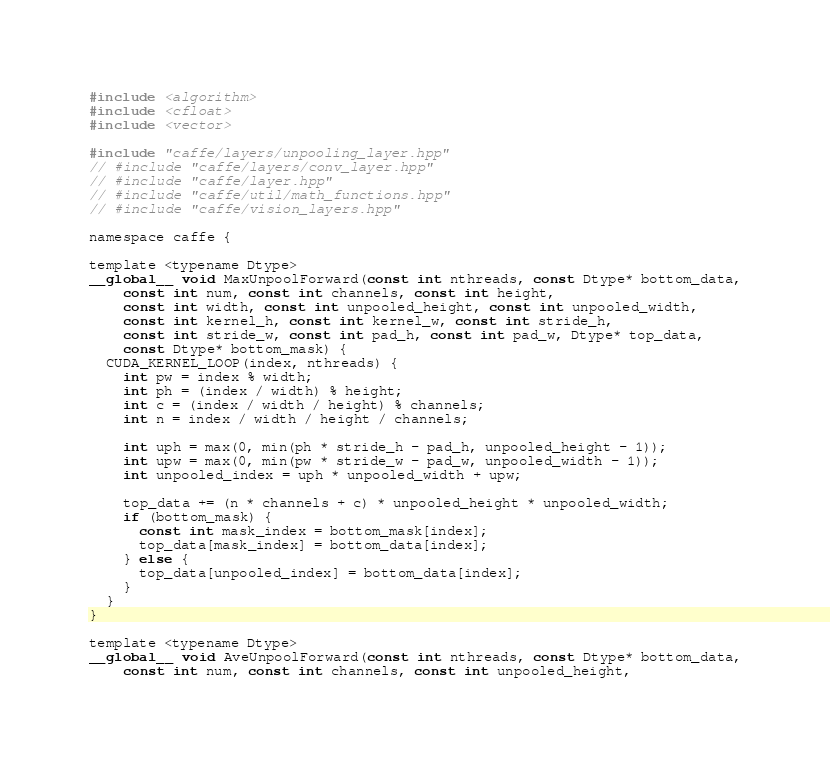<code> <loc_0><loc_0><loc_500><loc_500><_Cuda_>#include <algorithm>
#include <cfloat>
#include <vector>

#include "caffe/layers/unpooling_layer.hpp"
// #include "caffe/layers/conv_layer.hpp"
// #include "caffe/layer.hpp"
// #include "caffe/util/math_functions.hpp"
// #include "caffe/vision_layers.hpp"

namespace caffe {

template <typename Dtype>
__global__ void MaxUnpoolForward(const int nthreads, const Dtype* bottom_data,
    const int num, const int channels, const int height,
    const int width, const int unpooled_height, const int unpooled_width,
    const int kernel_h, const int kernel_w, const int stride_h,
    const int stride_w, const int pad_h, const int pad_w, Dtype* top_data,
    const Dtype* bottom_mask) {
  CUDA_KERNEL_LOOP(index, nthreads) {
    int pw = index % width;
    int ph = (index / width) % height;
    int c = (index / width / height) % channels;
    int n = index / width / height / channels;

    int uph = max(0, min(ph * stride_h - pad_h, unpooled_height - 1));
    int upw = max(0, min(pw * stride_w - pad_w, unpooled_width - 1));
    int unpooled_index = uph * unpooled_width + upw;

    top_data += (n * channels + c) * unpooled_height * unpooled_width;
    if (bottom_mask) {
      const int mask_index = bottom_mask[index];
      top_data[mask_index] = bottom_data[index];
    } else {
      top_data[unpooled_index] = bottom_data[index];
    }
  }
}

template <typename Dtype>
__global__ void AveUnpoolForward(const int nthreads, const Dtype* bottom_data,
    const int num, const int channels, const int unpooled_height,</code> 